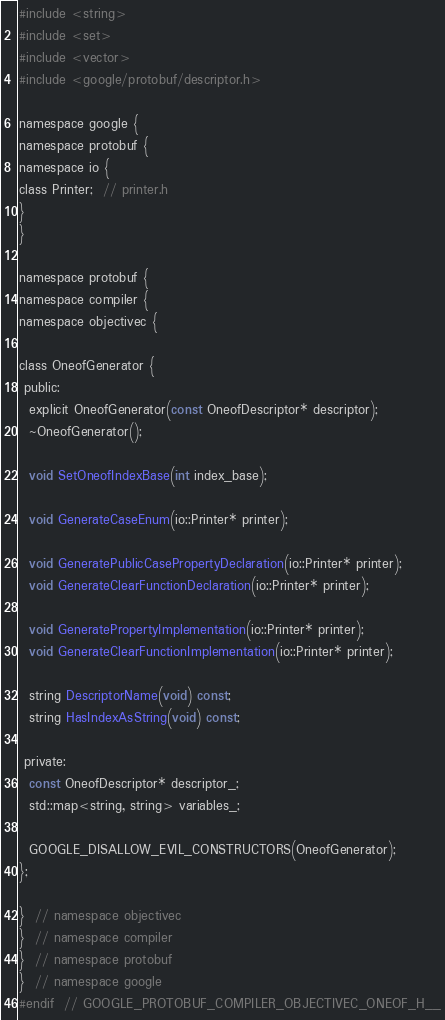<code> <loc_0><loc_0><loc_500><loc_500><_C_>
#include <string>
#include <set>
#include <vector>
#include <google/protobuf/descriptor.h>

namespace google {
namespace protobuf {
namespace io {
class Printer;  // printer.h
}
}

namespace protobuf {
namespace compiler {
namespace objectivec {

class OneofGenerator {
 public:
  explicit OneofGenerator(const OneofDescriptor* descriptor);
  ~OneofGenerator();

  void SetOneofIndexBase(int index_base);

  void GenerateCaseEnum(io::Printer* printer);

  void GeneratePublicCasePropertyDeclaration(io::Printer* printer);
  void GenerateClearFunctionDeclaration(io::Printer* printer);

  void GeneratePropertyImplementation(io::Printer* printer);
  void GenerateClearFunctionImplementation(io::Printer* printer);

  string DescriptorName(void) const;
  string HasIndexAsString(void) const;

 private:
  const OneofDescriptor* descriptor_;
  std::map<string, string> variables_;

  GOOGLE_DISALLOW_EVIL_CONSTRUCTORS(OneofGenerator);
};

}  // namespace objectivec
}  // namespace compiler
}  // namespace protobuf
}  // namespace google
#endif  // GOOGLE_PROTOBUF_COMPILER_OBJECTIVEC_ONEOF_H__
</code> 